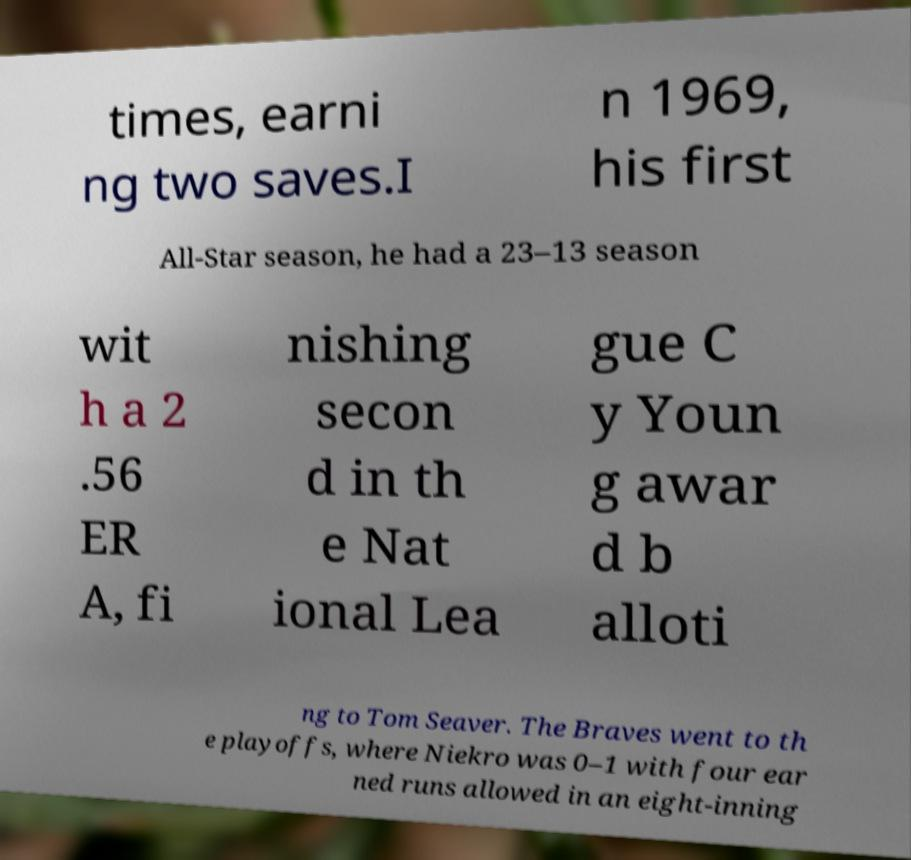Can you accurately transcribe the text from the provided image for me? times, earni ng two saves.I n 1969, his first All-Star season, he had a 23–13 season wit h a 2 .56 ER A, fi nishing secon d in th e Nat ional Lea gue C y Youn g awar d b alloti ng to Tom Seaver. The Braves went to th e playoffs, where Niekro was 0–1 with four ear ned runs allowed in an eight-inning 